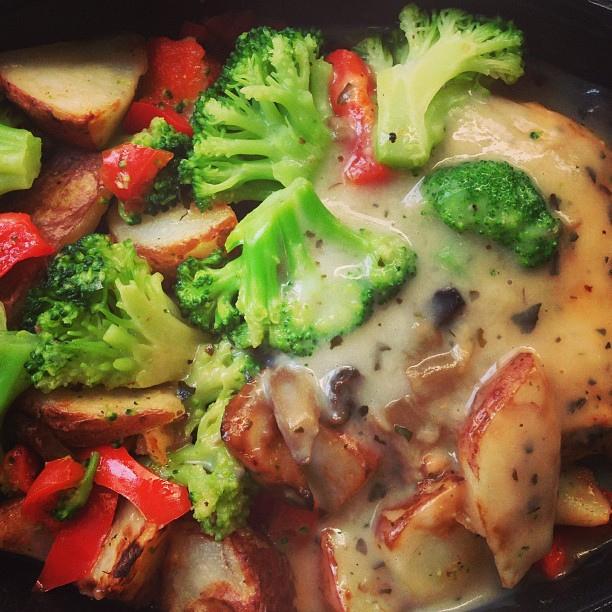Does this dish contain potatoes?
Concise answer only. Yes. What are the green objects?
Be succinct. Broccoli. What are the red objects?
Write a very short answer. Peppers. 